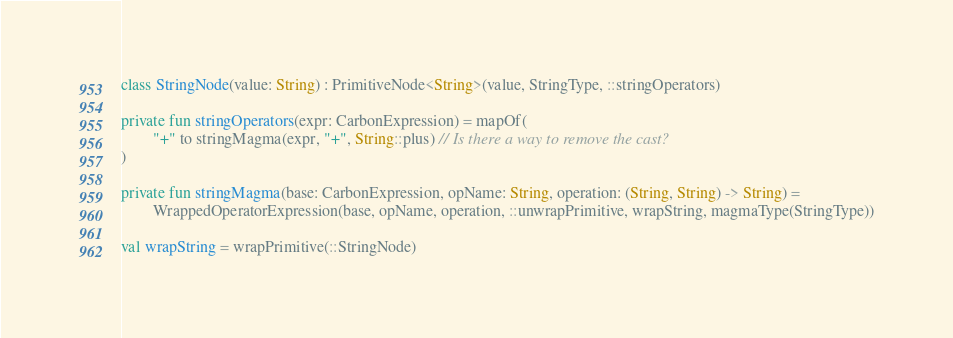<code> <loc_0><loc_0><loc_500><loc_500><_Kotlin_>class StringNode(value: String) : PrimitiveNode<String>(value, StringType, ::stringOperators)

private fun stringOperators(expr: CarbonExpression) = mapOf(
        "+" to stringMagma(expr, "+", String::plus) // Is there a way to remove the cast?
)

private fun stringMagma(base: CarbonExpression, opName: String, operation: (String, String) -> String) =
        WrappedOperatorExpression(base, opName, operation, ::unwrapPrimitive, wrapString, magmaType(StringType))

val wrapString = wrapPrimitive(::StringNode)</code> 